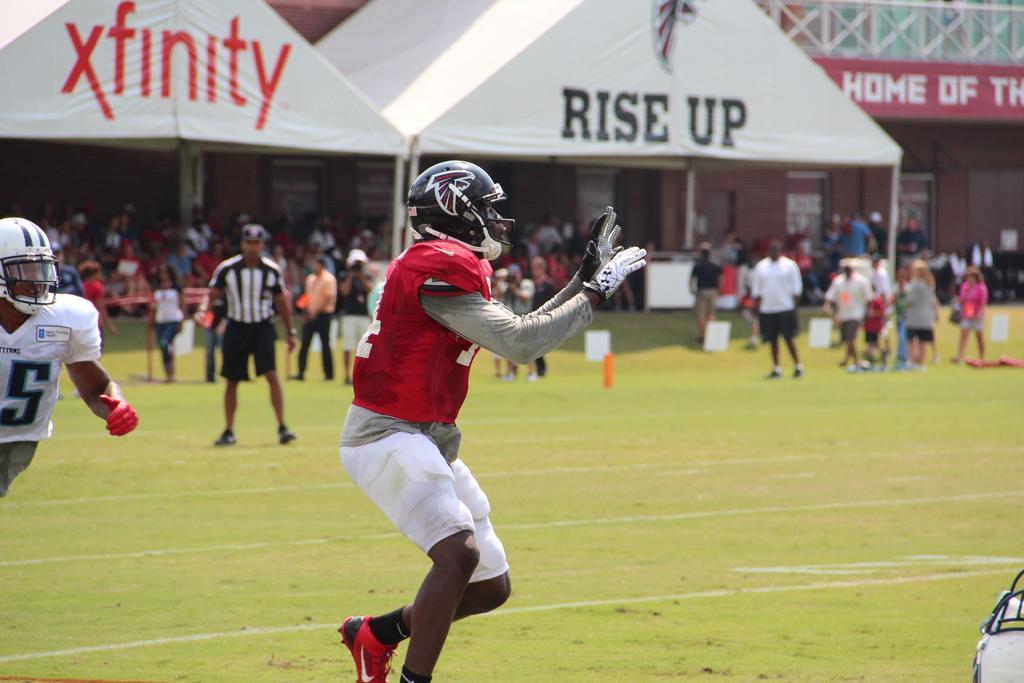In one or two sentences, can you explain what this image depicts? In this image we can see a person is standing. He is wearing red and white color dress and black helmet with gloves. Left side of the image one more man is there who is wearing white color t-shirt with with white helmet. Background of the image people are standing. At the top of the image white color shelters and railing is there. 